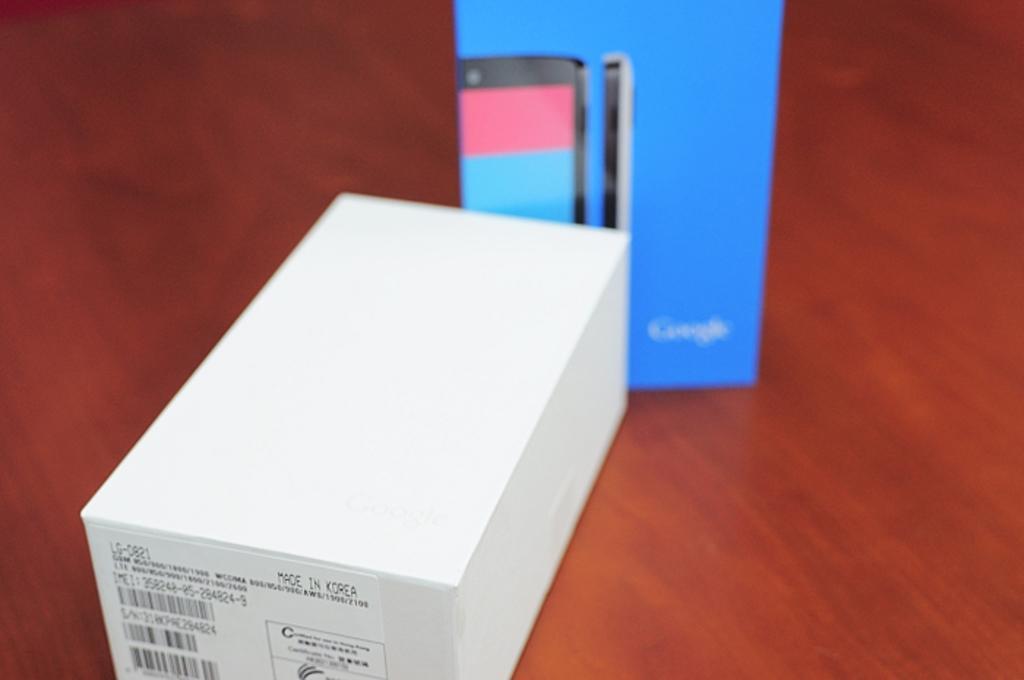<image>
Share a concise interpretation of the image provided. A blue box from Google next to a white box on a wooden surface. 